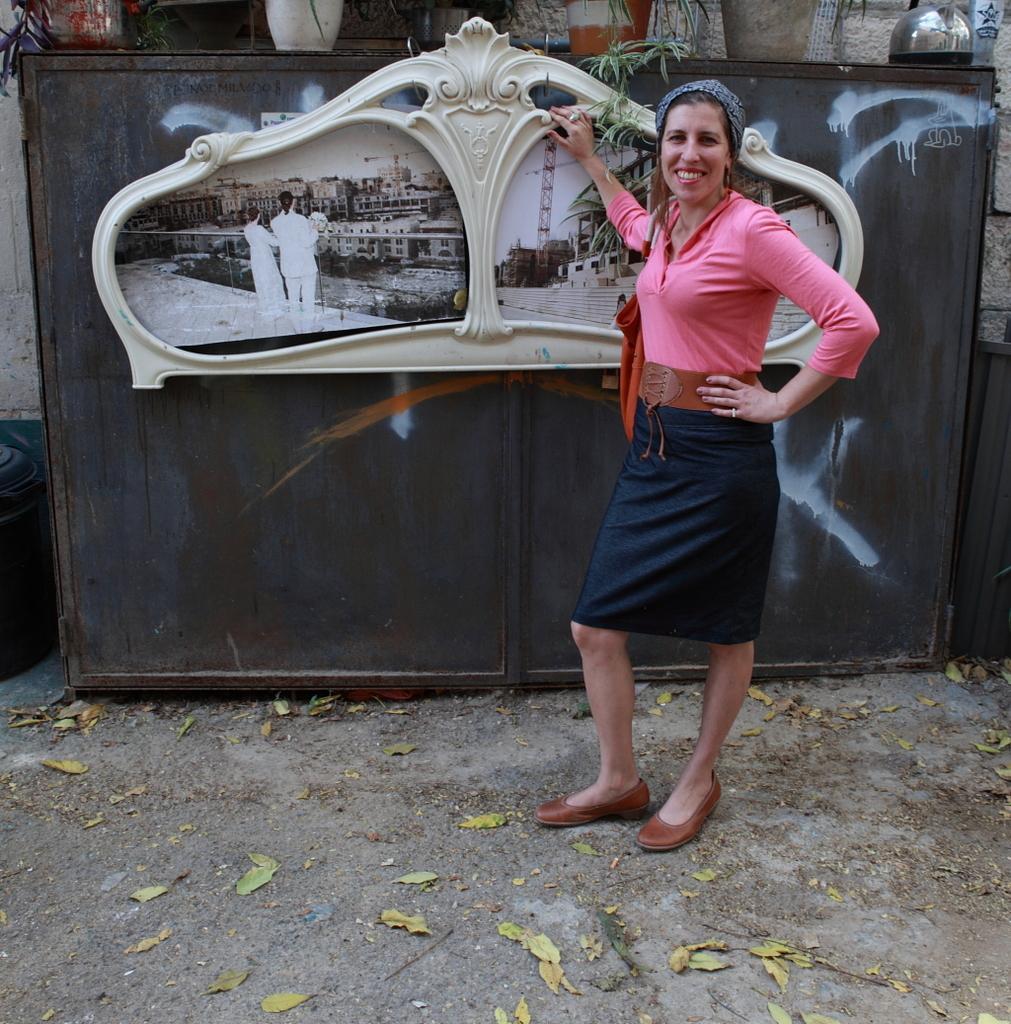Please provide a concise description of this image. In this picture we can see a woman standing on the ground and smiling, house plants, photos and in photos we can see steps, buildings and two persons standing at the fence. 